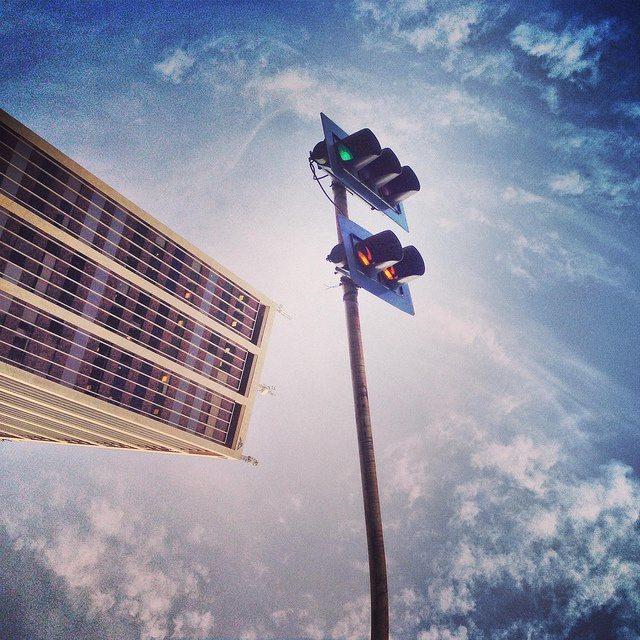Describe the objects in this image and their specific colors. I can see traffic light in blue, navy, black, purple, and gray tones and traffic light in blue, navy, and purple tones in this image. 